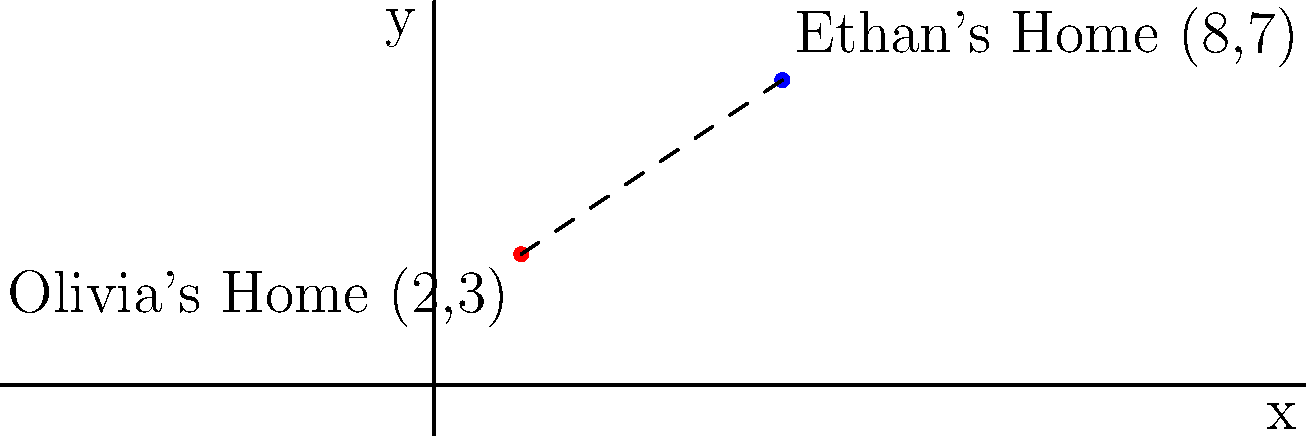In Mlissa's latest romance novel, the main characters Olivia and Ethan live in different parts of town. On a coordinate plane, Olivia's home is located at (2,3) and Ethan's home is at (8,7). What is the straight-line distance between their homes? To find the distance between two points on a coordinate plane, we can use the distance formula:

$$ d = \sqrt{(x_2 - x_1)^2 + (y_2 - y_1)^2} $$

Where $(x_1, y_1)$ is the coordinate of the first point and $(x_2, y_2)$ is the coordinate of the second point.

Let's plug in the values:
$(x_1, y_1) = (2, 3)$ for Olivia's home
$(x_2, y_2) = (8, 7)$ for Ethan's home

$$ d = \sqrt{(8 - 2)^2 + (7 - 3)^2} $$

Simplify:
$$ d = \sqrt{6^2 + 4^2} $$
$$ d = \sqrt{36 + 16} $$
$$ d = \sqrt{52} $$

Simplify the square root:
$$ d = 2\sqrt{13} $$

Therefore, the straight-line distance between Olivia's and Ethan's homes is $2\sqrt{13}$ units.
Answer: $2\sqrt{13}$ units 